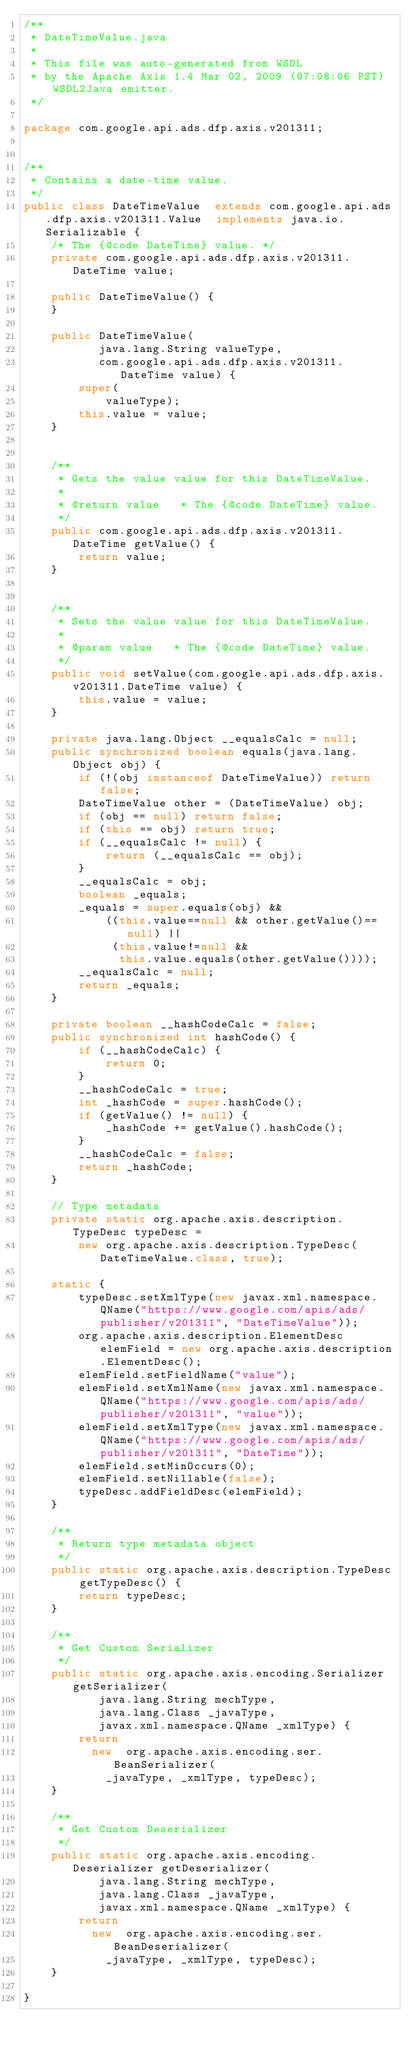<code> <loc_0><loc_0><loc_500><loc_500><_Java_>/**
 * DateTimeValue.java
 *
 * This file was auto-generated from WSDL
 * by the Apache Axis 1.4 Mar 02, 2009 (07:08:06 PST) WSDL2Java emitter.
 */

package com.google.api.ads.dfp.axis.v201311;


/**
 * Contains a date-time value.
 */
public class DateTimeValue  extends com.google.api.ads.dfp.axis.v201311.Value  implements java.io.Serializable {
    /* The {@code DateTime} value. */
    private com.google.api.ads.dfp.axis.v201311.DateTime value;

    public DateTimeValue() {
    }

    public DateTimeValue(
           java.lang.String valueType,
           com.google.api.ads.dfp.axis.v201311.DateTime value) {
        super(
            valueType);
        this.value = value;
    }


    /**
     * Gets the value value for this DateTimeValue.
     * 
     * @return value   * The {@code DateTime} value.
     */
    public com.google.api.ads.dfp.axis.v201311.DateTime getValue() {
        return value;
    }


    /**
     * Sets the value value for this DateTimeValue.
     * 
     * @param value   * The {@code DateTime} value.
     */
    public void setValue(com.google.api.ads.dfp.axis.v201311.DateTime value) {
        this.value = value;
    }

    private java.lang.Object __equalsCalc = null;
    public synchronized boolean equals(java.lang.Object obj) {
        if (!(obj instanceof DateTimeValue)) return false;
        DateTimeValue other = (DateTimeValue) obj;
        if (obj == null) return false;
        if (this == obj) return true;
        if (__equalsCalc != null) {
            return (__equalsCalc == obj);
        }
        __equalsCalc = obj;
        boolean _equals;
        _equals = super.equals(obj) && 
            ((this.value==null && other.getValue()==null) || 
             (this.value!=null &&
              this.value.equals(other.getValue())));
        __equalsCalc = null;
        return _equals;
    }

    private boolean __hashCodeCalc = false;
    public synchronized int hashCode() {
        if (__hashCodeCalc) {
            return 0;
        }
        __hashCodeCalc = true;
        int _hashCode = super.hashCode();
        if (getValue() != null) {
            _hashCode += getValue().hashCode();
        }
        __hashCodeCalc = false;
        return _hashCode;
    }

    // Type metadata
    private static org.apache.axis.description.TypeDesc typeDesc =
        new org.apache.axis.description.TypeDesc(DateTimeValue.class, true);

    static {
        typeDesc.setXmlType(new javax.xml.namespace.QName("https://www.google.com/apis/ads/publisher/v201311", "DateTimeValue"));
        org.apache.axis.description.ElementDesc elemField = new org.apache.axis.description.ElementDesc();
        elemField.setFieldName("value");
        elemField.setXmlName(new javax.xml.namespace.QName("https://www.google.com/apis/ads/publisher/v201311", "value"));
        elemField.setXmlType(new javax.xml.namespace.QName("https://www.google.com/apis/ads/publisher/v201311", "DateTime"));
        elemField.setMinOccurs(0);
        elemField.setNillable(false);
        typeDesc.addFieldDesc(elemField);
    }

    /**
     * Return type metadata object
     */
    public static org.apache.axis.description.TypeDesc getTypeDesc() {
        return typeDesc;
    }

    /**
     * Get Custom Serializer
     */
    public static org.apache.axis.encoding.Serializer getSerializer(
           java.lang.String mechType, 
           java.lang.Class _javaType,  
           javax.xml.namespace.QName _xmlType) {
        return 
          new  org.apache.axis.encoding.ser.BeanSerializer(
            _javaType, _xmlType, typeDesc);
    }

    /**
     * Get Custom Deserializer
     */
    public static org.apache.axis.encoding.Deserializer getDeserializer(
           java.lang.String mechType, 
           java.lang.Class _javaType,  
           javax.xml.namespace.QName _xmlType) {
        return 
          new  org.apache.axis.encoding.ser.BeanDeserializer(
            _javaType, _xmlType, typeDesc);
    }

}
</code> 